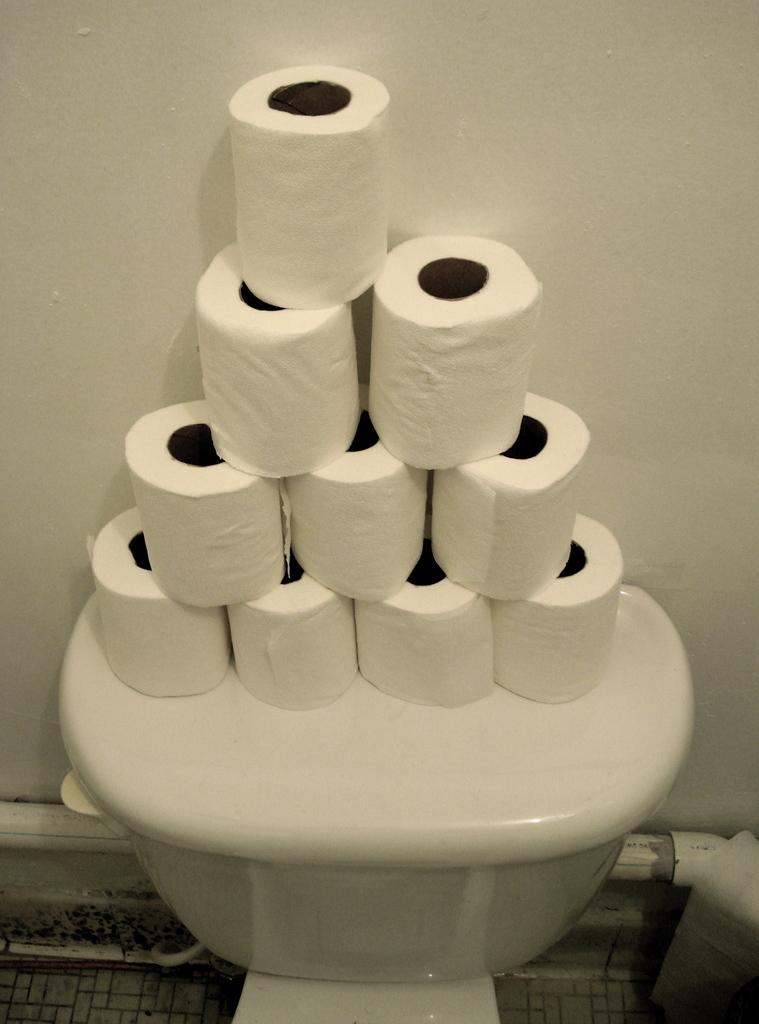What is placed on the flush tank in the image? There are toilet paper rolls on the flush tank. What can be seen in the background of the image? There is a wall in the background of the image. What type of face can be seen on the tank in the image? There is no face present on the tank in the image. 